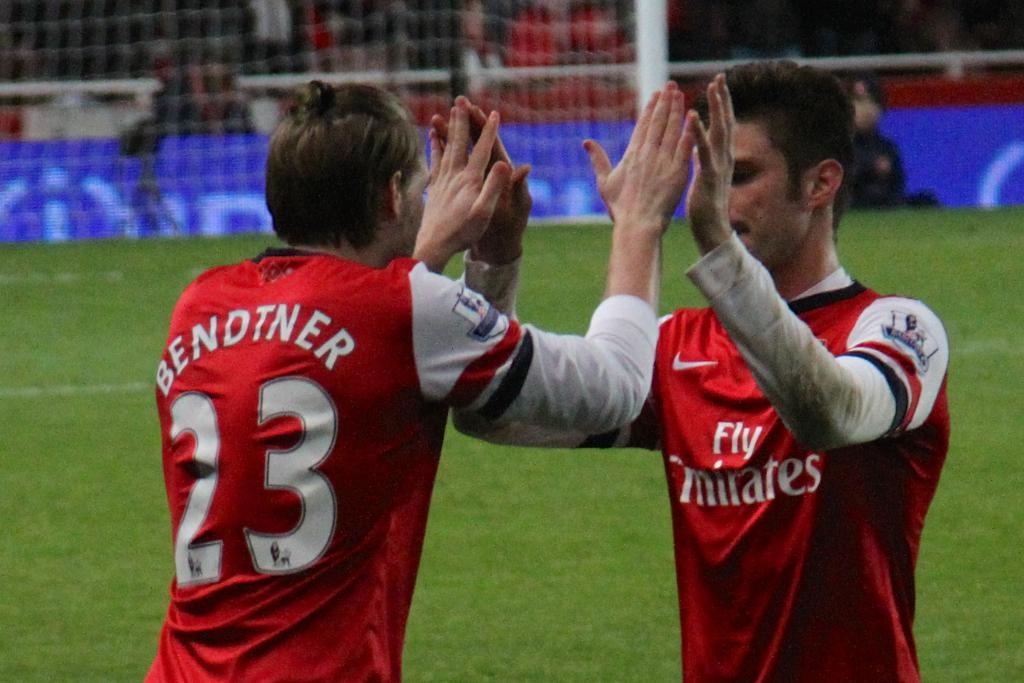<image>
Provide a brief description of the given image. A player with a 23 jersey high fives another team mate 